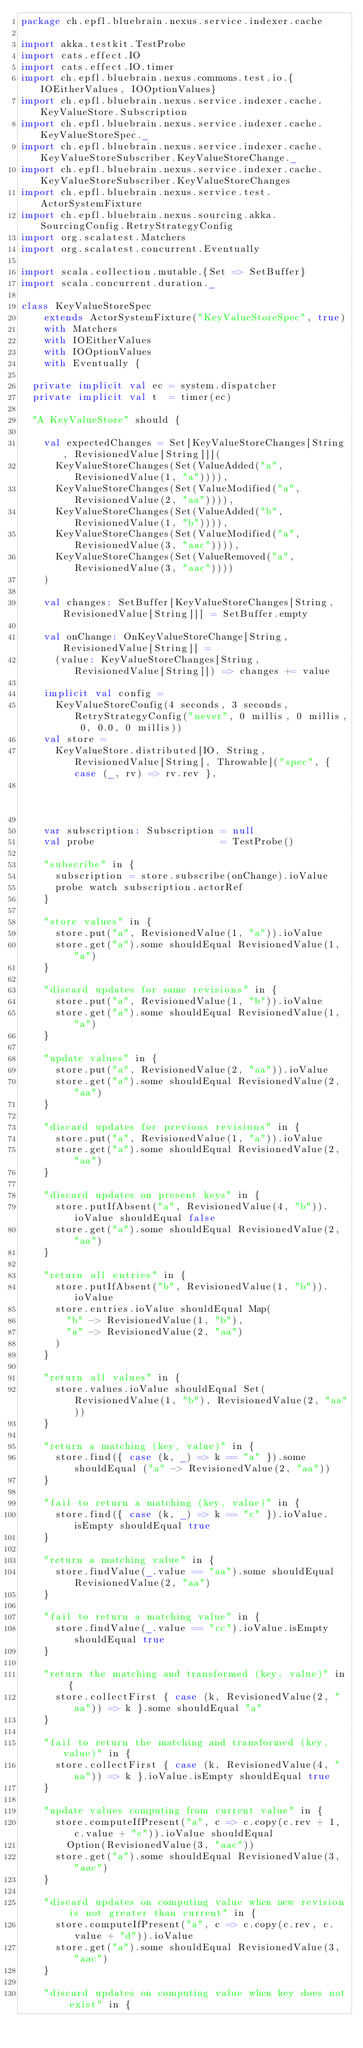<code> <loc_0><loc_0><loc_500><loc_500><_Scala_>package ch.epfl.bluebrain.nexus.service.indexer.cache

import akka.testkit.TestProbe
import cats.effect.IO
import cats.effect.IO.timer
import ch.epfl.bluebrain.nexus.commons.test.io.{IOEitherValues, IOOptionValues}
import ch.epfl.bluebrain.nexus.service.indexer.cache.KeyValueStore.Subscription
import ch.epfl.bluebrain.nexus.service.indexer.cache.KeyValueStoreSpec._
import ch.epfl.bluebrain.nexus.service.indexer.cache.KeyValueStoreSubscriber.KeyValueStoreChange._
import ch.epfl.bluebrain.nexus.service.indexer.cache.KeyValueStoreSubscriber.KeyValueStoreChanges
import ch.epfl.bluebrain.nexus.service.test.ActorSystemFixture
import ch.epfl.bluebrain.nexus.sourcing.akka.SourcingConfig.RetryStrategyConfig
import org.scalatest.Matchers
import org.scalatest.concurrent.Eventually

import scala.collection.mutable.{Set => SetBuffer}
import scala.concurrent.duration._

class KeyValueStoreSpec
    extends ActorSystemFixture("KeyValueStoreSpec", true)
    with Matchers
    with IOEitherValues
    with IOOptionValues
    with Eventually {

  private implicit val ec = system.dispatcher
  private implicit val t  = timer(ec)

  "A KeyValueStore" should {

    val expectedChanges = Set[KeyValueStoreChanges[String, RevisionedValue[String]]](
      KeyValueStoreChanges(Set(ValueAdded("a", RevisionedValue(1, "a")))),
      KeyValueStoreChanges(Set(ValueModified("a", RevisionedValue(2, "aa")))),
      KeyValueStoreChanges(Set(ValueAdded("b", RevisionedValue(1, "b")))),
      KeyValueStoreChanges(Set(ValueModified("a", RevisionedValue(3, "aac")))),
      KeyValueStoreChanges(Set(ValueRemoved("a", RevisionedValue(3, "aac"))))
    )

    val changes: SetBuffer[KeyValueStoreChanges[String, RevisionedValue[String]]] = SetBuffer.empty

    val onChange: OnKeyValueStoreChange[String, RevisionedValue[String]] =
      (value: KeyValueStoreChanges[String, RevisionedValue[String]]) => changes += value

    implicit val config =
      KeyValueStoreConfig(4 seconds, 3 seconds, RetryStrategyConfig("never", 0 millis, 0 millis, 0, 0.0, 0 millis))
    val store =
      KeyValueStore.distributed[IO, String, RevisionedValue[String], Throwable]("spec", { case (_, rv) => rv.rev },
                                                                                ErrorWrapper)

    var subscription: Subscription = null
    val probe                      = TestProbe()

    "subscribe" in {
      subscription = store.subscribe(onChange).ioValue
      probe watch subscription.actorRef
    }

    "store values" in {
      store.put("a", RevisionedValue(1, "a")).ioValue
      store.get("a").some shouldEqual RevisionedValue(1, "a")
    }

    "discard updates for same revisions" in {
      store.put("a", RevisionedValue(1, "b")).ioValue
      store.get("a").some shouldEqual RevisionedValue(1, "a")
    }

    "update values" in {
      store.put("a", RevisionedValue(2, "aa")).ioValue
      store.get("a").some shouldEqual RevisionedValue(2, "aa")
    }

    "discard updates for previous revisions" in {
      store.put("a", RevisionedValue(1, "a")).ioValue
      store.get("a").some shouldEqual RevisionedValue(2, "aa")
    }

    "discard updates on present keys" in {
      store.putIfAbsent("a", RevisionedValue(4, "b")).ioValue shouldEqual false
      store.get("a").some shouldEqual RevisionedValue(2, "aa")
    }

    "return all entries" in {
      store.putIfAbsent("b", RevisionedValue(1, "b")).ioValue
      store.entries.ioValue shouldEqual Map(
        "b" -> RevisionedValue(1, "b"),
        "a" -> RevisionedValue(2, "aa")
      )
    }

    "return all values" in {
      store.values.ioValue shouldEqual Set(RevisionedValue(1, "b"), RevisionedValue(2, "aa"))
    }

    "return a matching (key, value)" in {
      store.find({ case (k, _) => k == "a" }).some shouldEqual ("a" -> RevisionedValue(2, "aa"))
    }

    "fail to return a matching (key, value)" in {
      store.find({ case (k, _) => k == "c" }).ioValue.isEmpty shouldEqual true
    }

    "return a matching value" in {
      store.findValue(_.value == "aa").some shouldEqual RevisionedValue(2, "aa")
    }

    "fail to return a matching value" in {
      store.findValue(_.value == "cc").ioValue.isEmpty shouldEqual true
    }

    "return the matching and transformed (key, value)" in {
      store.collectFirst { case (k, RevisionedValue(2, "aa")) => k }.some shouldEqual "a"
    }

    "fail to return the matching and transformed (key, value)" in {
      store.collectFirst { case (k, RevisionedValue(4, "aa")) => k }.ioValue.isEmpty shouldEqual true
    }

    "update values computing from current value" in {
      store.computeIfPresent("a", c => c.copy(c.rev + 1, c.value + "c")).ioValue shouldEqual
        Option(RevisionedValue(3, "aac"))
      store.get("a").some shouldEqual RevisionedValue(3, "aac")
    }

    "discard updates on computing value when new revision is not greater than current" in {
      store.computeIfPresent("a", c => c.copy(c.rev, c.value + "d")).ioValue
      store.get("a").some shouldEqual RevisionedValue(3, "aac")
    }

    "discard updates on computing value when key does not exist" in {</code> 